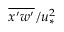<formula> <loc_0><loc_0><loc_500><loc_500>\overline { { x ^ { \prime } w ^ { \prime } } } / u _ { * } ^ { 2 }</formula> 